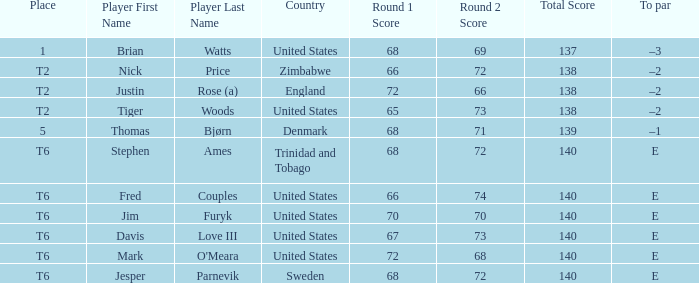What was the tournament official (to) par for the player with a score of 68-71=139? –1. 